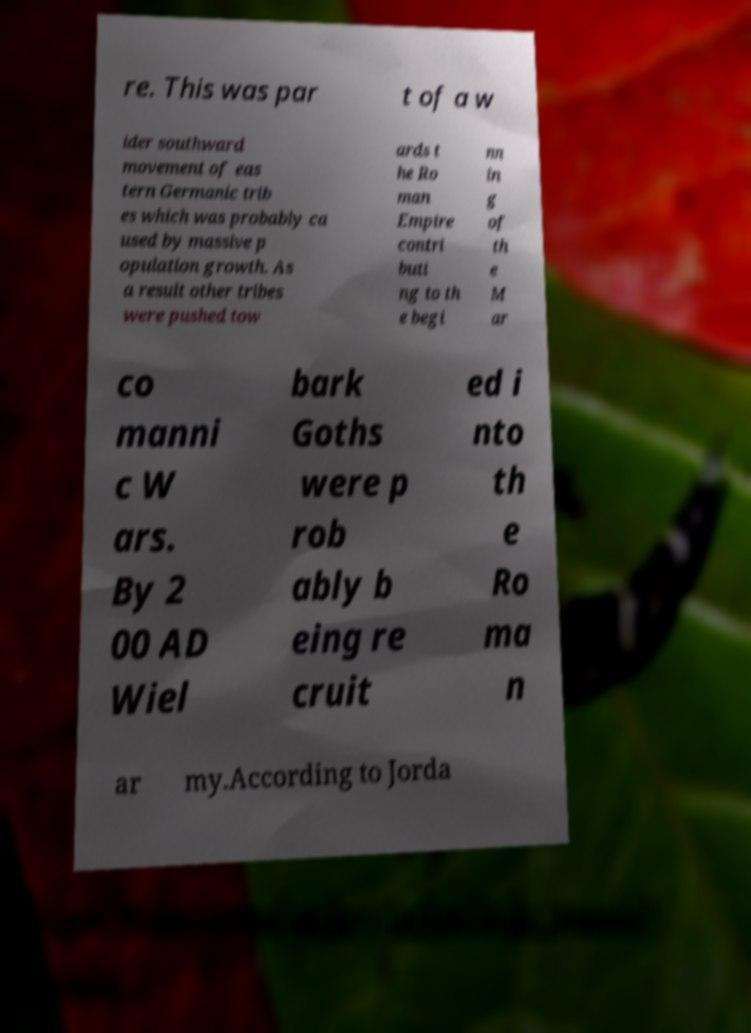Please identify and transcribe the text found in this image. re. This was par t of a w ider southward movement of eas tern Germanic trib es which was probably ca used by massive p opulation growth. As a result other tribes were pushed tow ards t he Ro man Empire contri buti ng to th e begi nn in g of th e M ar co manni c W ars. By 2 00 AD Wiel bark Goths were p rob ably b eing re cruit ed i nto th e Ro ma n ar my.According to Jorda 